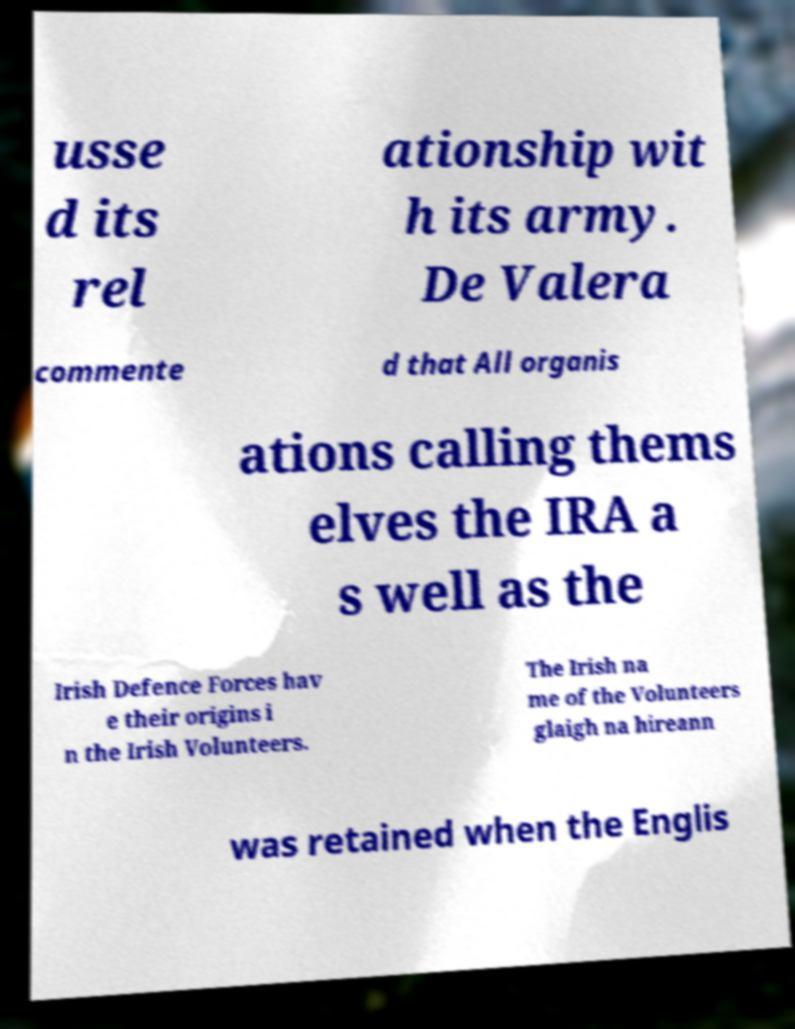Can you accurately transcribe the text from the provided image for me? usse d its rel ationship wit h its army. De Valera commente d that All organis ations calling thems elves the IRA a s well as the Irish Defence Forces hav e their origins i n the Irish Volunteers. The Irish na me of the Volunteers glaigh na hireann was retained when the Englis 